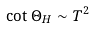Convert formula to latex. <formula><loc_0><loc_0><loc_500><loc_500>\cot \Theta _ { H } \sim T ^ { 2 }</formula> 